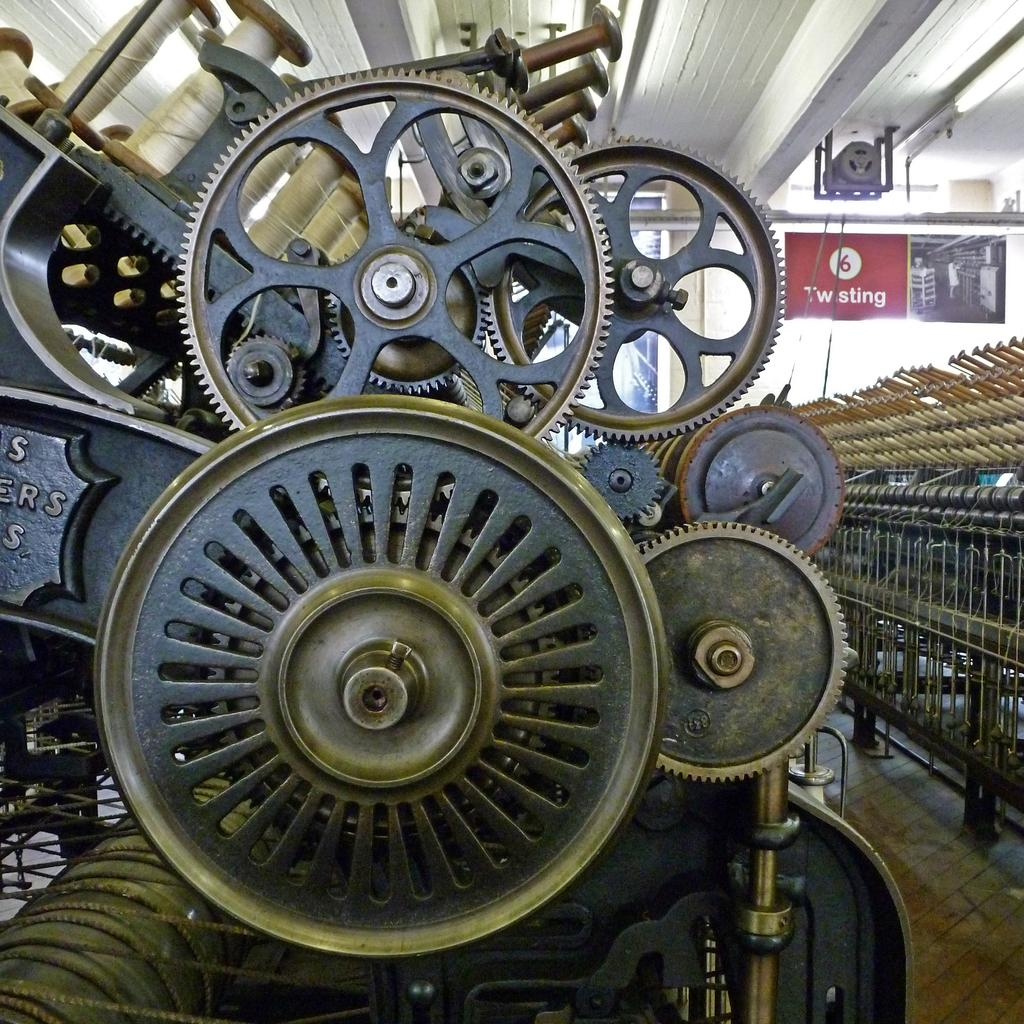What is the main object in the picture? There is a rotor in the picture. What can be seen on the left side of the picture? There is equipment on the left side of the picture. What is present on the right side of the picture? There are objects on the right side of the picture. What is visible in the background of the picture? There is a door in the background of the picture. What type of harmony is being played by the musicians in the picture? There are no musicians or instruments present in the picture, so it is not possible to determine if any harmony is being played. 